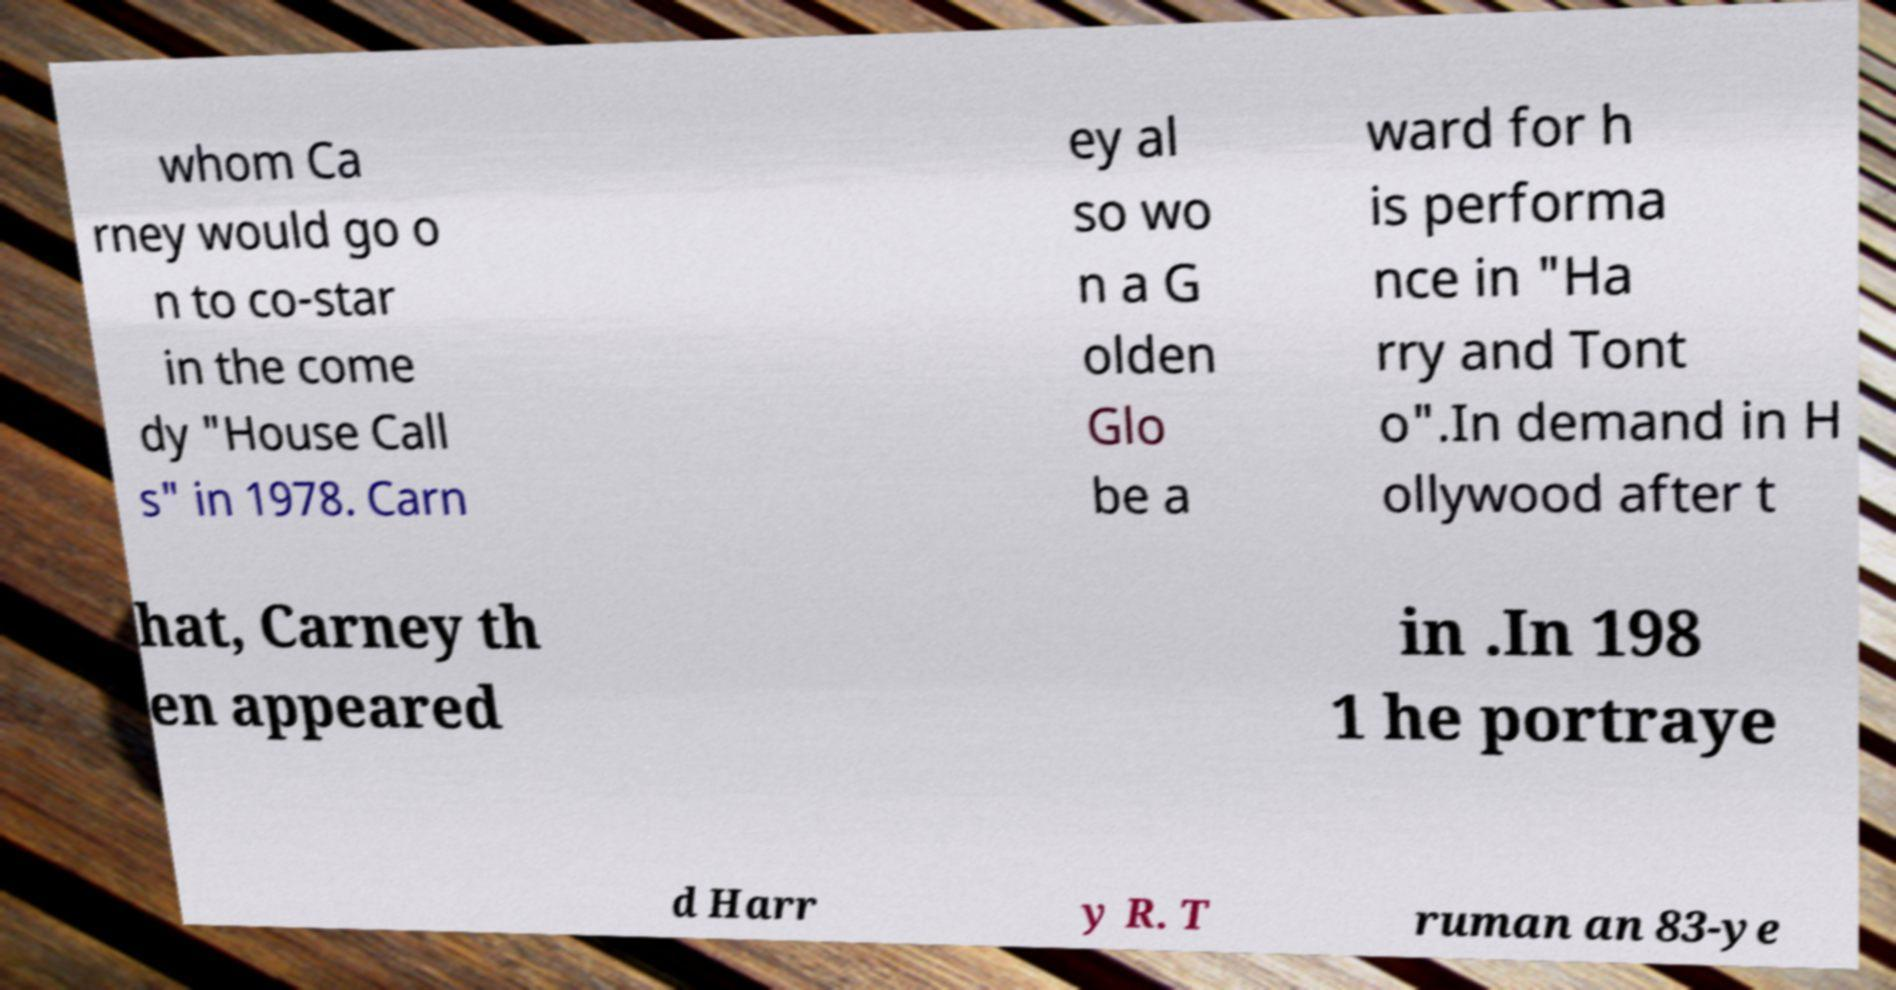I need the written content from this picture converted into text. Can you do that? whom Ca rney would go o n to co-star in the come dy "House Call s" in 1978. Carn ey al so wo n a G olden Glo be a ward for h is performa nce in "Ha rry and Tont o".In demand in H ollywood after t hat, Carney th en appeared in .In 198 1 he portraye d Harr y R. T ruman an 83-ye 